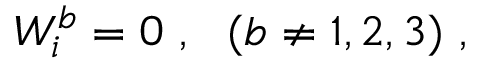<formula> <loc_0><loc_0><loc_500><loc_500>W _ { i } ^ { b } = 0 \ , \ \ ( b \ne 1 , 2 , 3 ) \ ,</formula> 